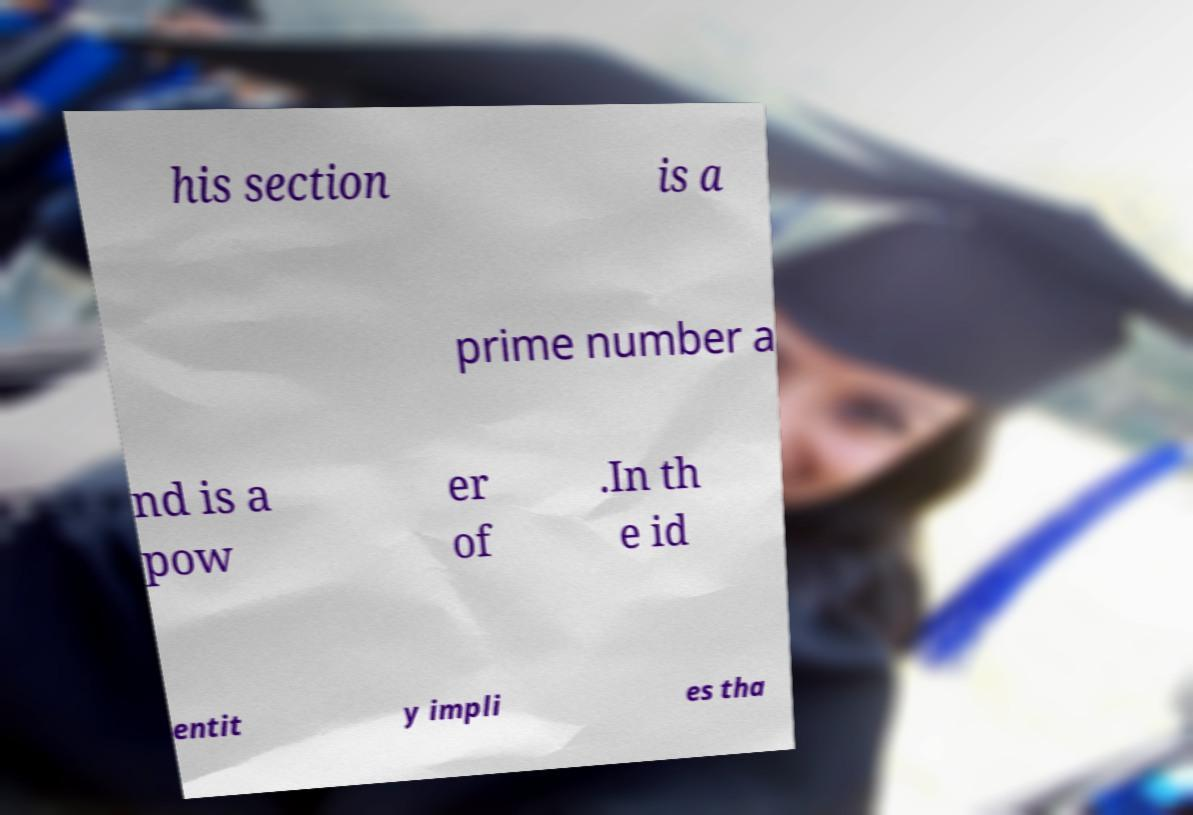Please read and relay the text visible in this image. What does it say? his section is a prime number a nd is a pow er of .In th e id entit y impli es tha 